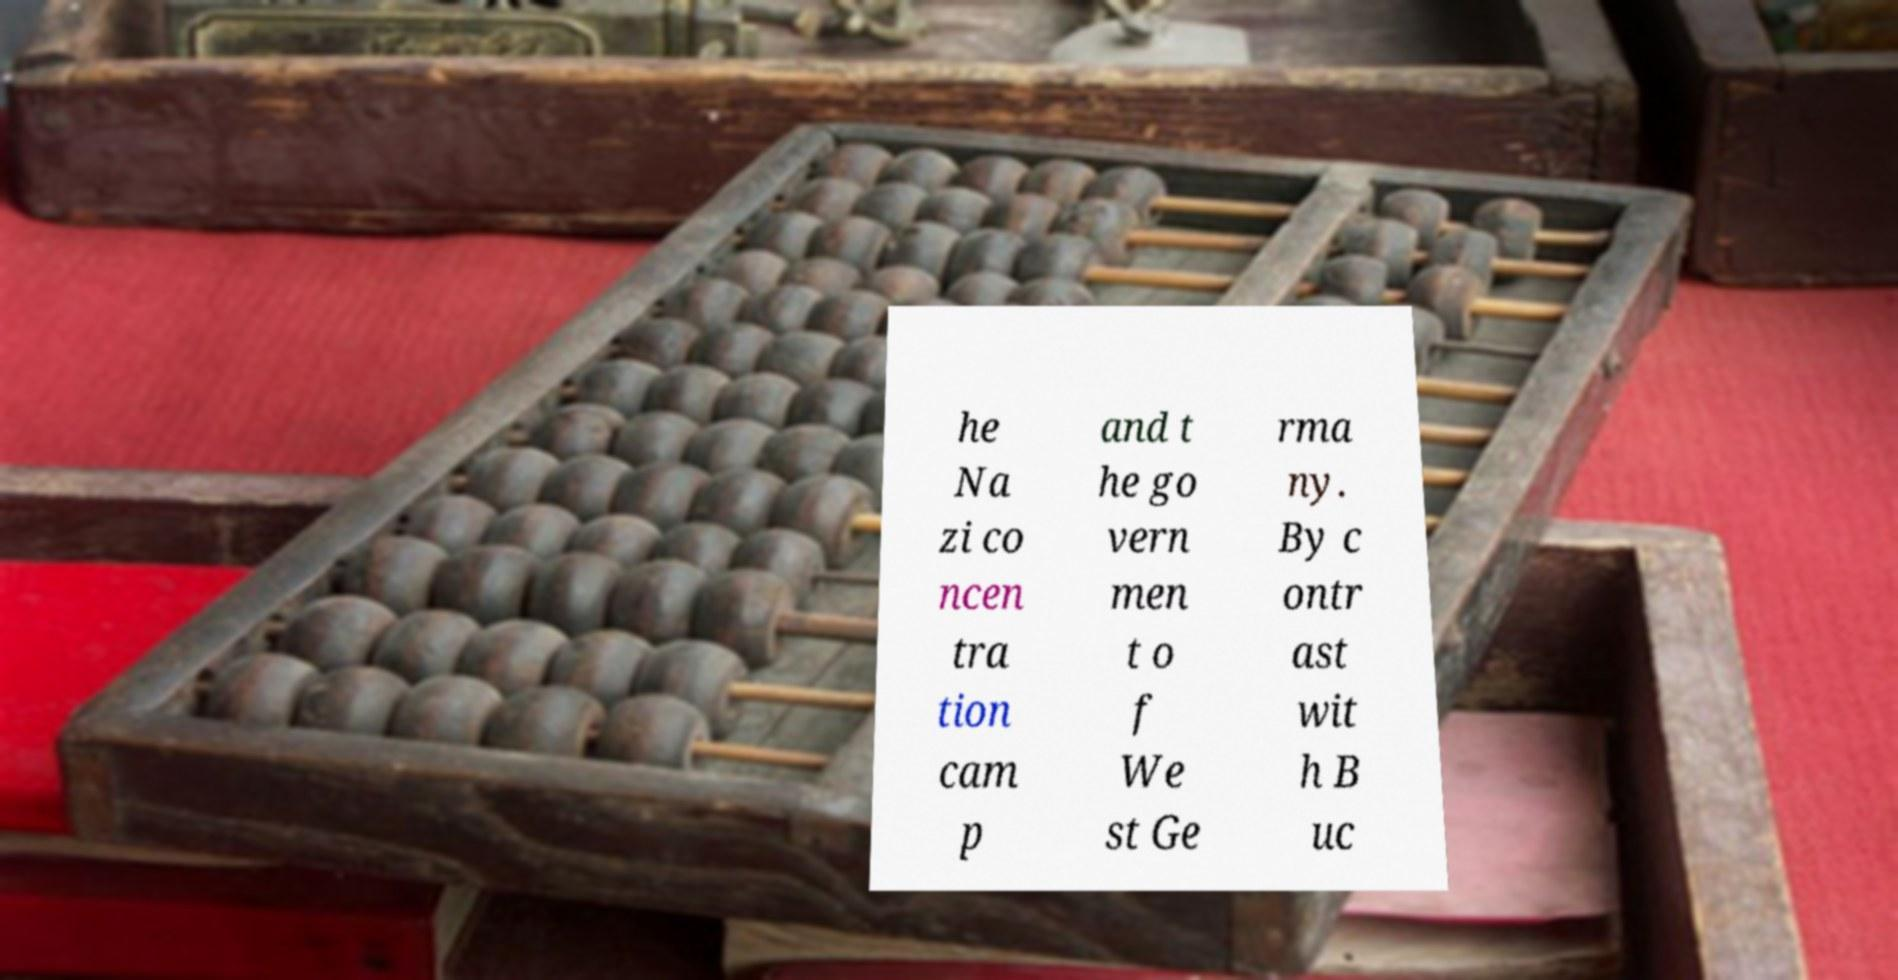Can you read and provide the text displayed in the image?This photo seems to have some interesting text. Can you extract and type it out for me? he Na zi co ncen tra tion cam p and t he go vern men t o f We st Ge rma ny. By c ontr ast wit h B uc 